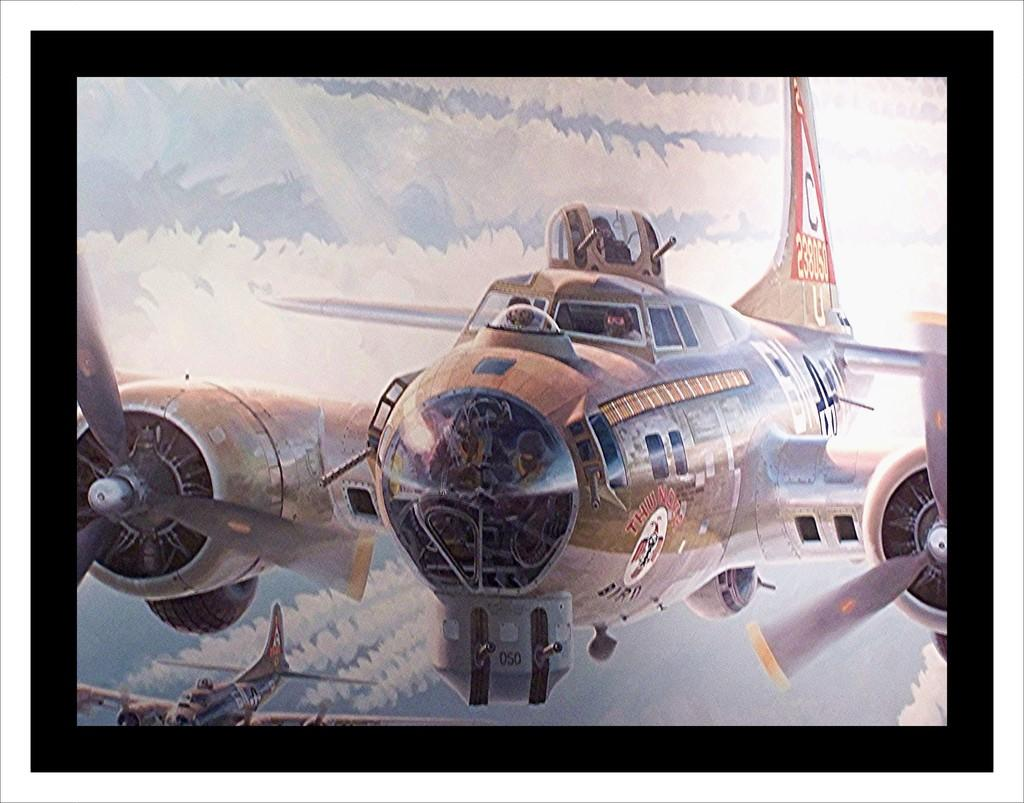What is happening in the image involving the planes? There are planes in the air, and people are inside them. Can you describe any specific details about the planes? Smoke is coming out from one of the planes. What can be seen in the background of the image? The sky is visible in the background. Where are the plants located in the image? There are no plants visible in the image. What type of cup is being used by the people inside the planes? There is no cup visible in the image, as it focuses on the planes and the smoke. 